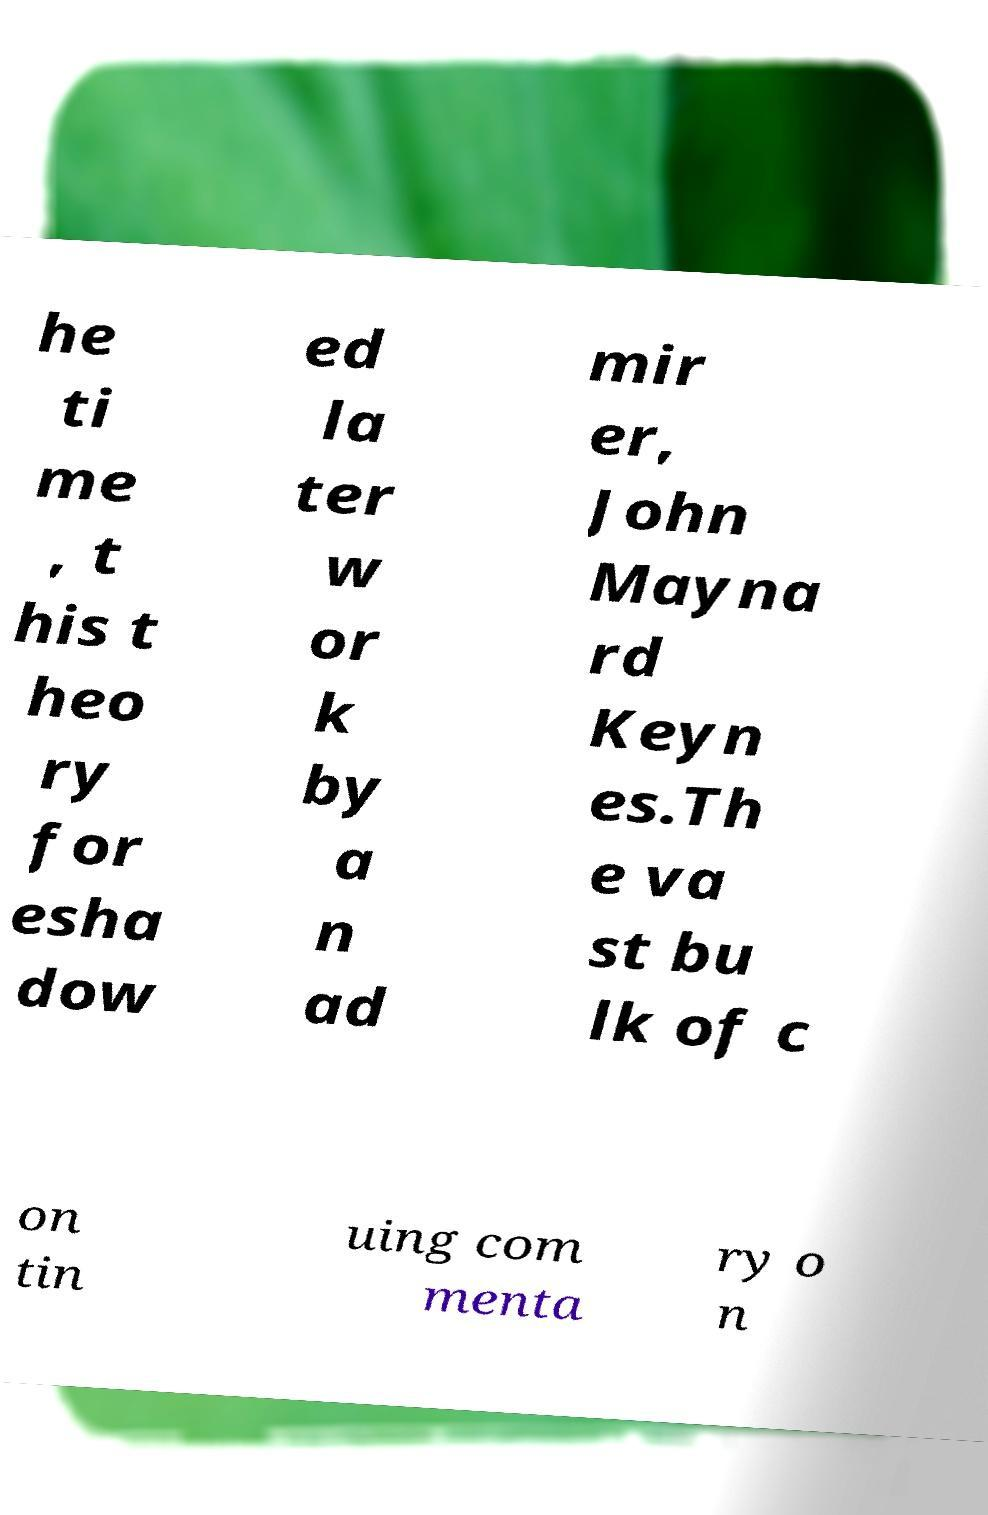Can you read and provide the text displayed in the image?This photo seems to have some interesting text. Can you extract and type it out for me? he ti me , t his t heo ry for esha dow ed la ter w or k by a n ad mir er, John Mayna rd Keyn es.Th e va st bu lk of c on tin uing com menta ry o n 